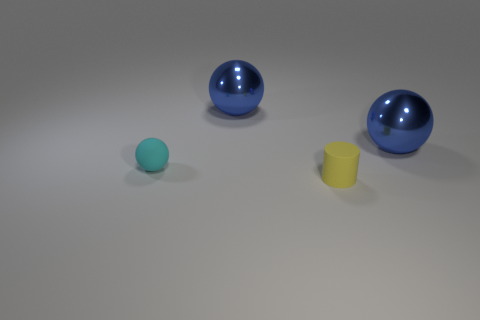Add 1 big cyan cubes. How many objects exist? 5 Subtract all cylinders. How many objects are left? 3 Add 3 cyan objects. How many cyan objects exist? 4 Subtract 2 blue spheres. How many objects are left? 2 Subtract all tiny objects. Subtract all gray metal cylinders. How many objects are left? 2 Add 4 tiny cyan objects. How many tiny cyan objects are left? 5 